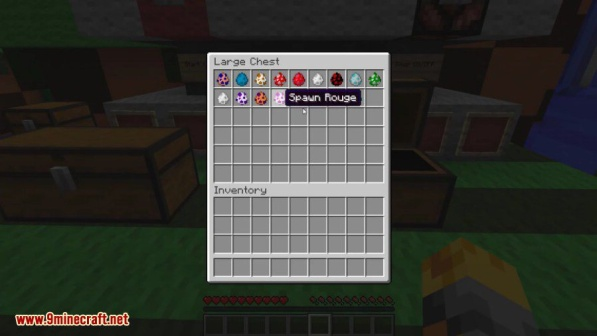Imagine the player uses the spawn eggs. What kind of scene could unfold? If the player uses the spawn eggs, a lively and potentially chaotic scene could unfold. Depending on the types of creatures summoned, there could be peaceful animals like cows, sheep, or chickens wandering around, or more dangerous mobs like creepers, zombies, or skeletons appearing. This could turn the tranquil base into a bustling hub of activity, with the player needing to manage and perhaps fend off the creatures. It could lead to battles, resource gathering, or even the establishment of new farms and defenses. The sudden influx of creatures would certainly bring an element of excitement and unpredictability to the player's environment. What would happen if the player accidentally spawns a Wither? If the player accidentally spawns a Wither, it would dramatically escalate the situation. The Wither is one of the most powerful hostile mobs in Minecraft, known for its destructive capabilities and strength. It would start attacking the player and any nearby creatures, causing significant damage to the base and surrounding area. The player would have to act quickly to either escape or prepare for a challenging battle. They might need to use powerful weapons, armor, and various potions to survive and defeat the Wither. This accidental spawning could turn the player's base from a serene haven into a war zone, requiring skilled and strategic gameplay to handle the chaos. 